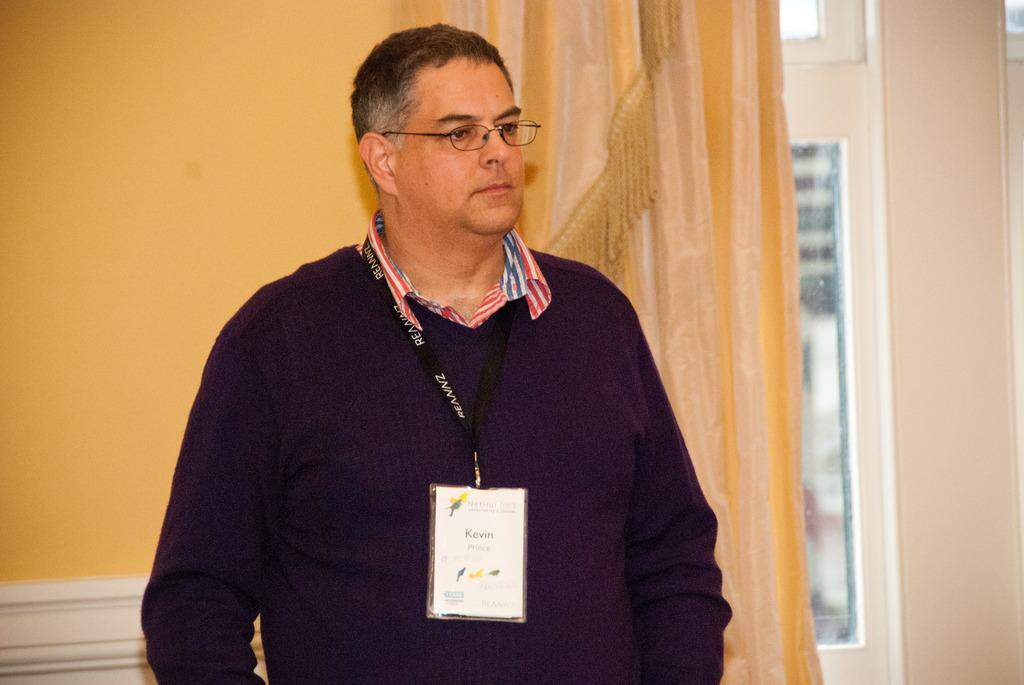What can be seen in the image? There is a person in the image. What is the person wearing? The person is wearing a sweatshirt. Does the person have any identification in the image? Yes, the person has an identity card. What type of eyewear is the person wearing? The person is wearing spectacles. What can be seen in the background of the image? There is a wall, curtains, and glass windows in the background of the image. What type of celery is being used as earrings in the image? There is no celery or earrings present in the image. What type of transport is visible in the image? There is no transport visible in the image; it features a person with an identity card and a background with a wall, curtains, and glass windows. 